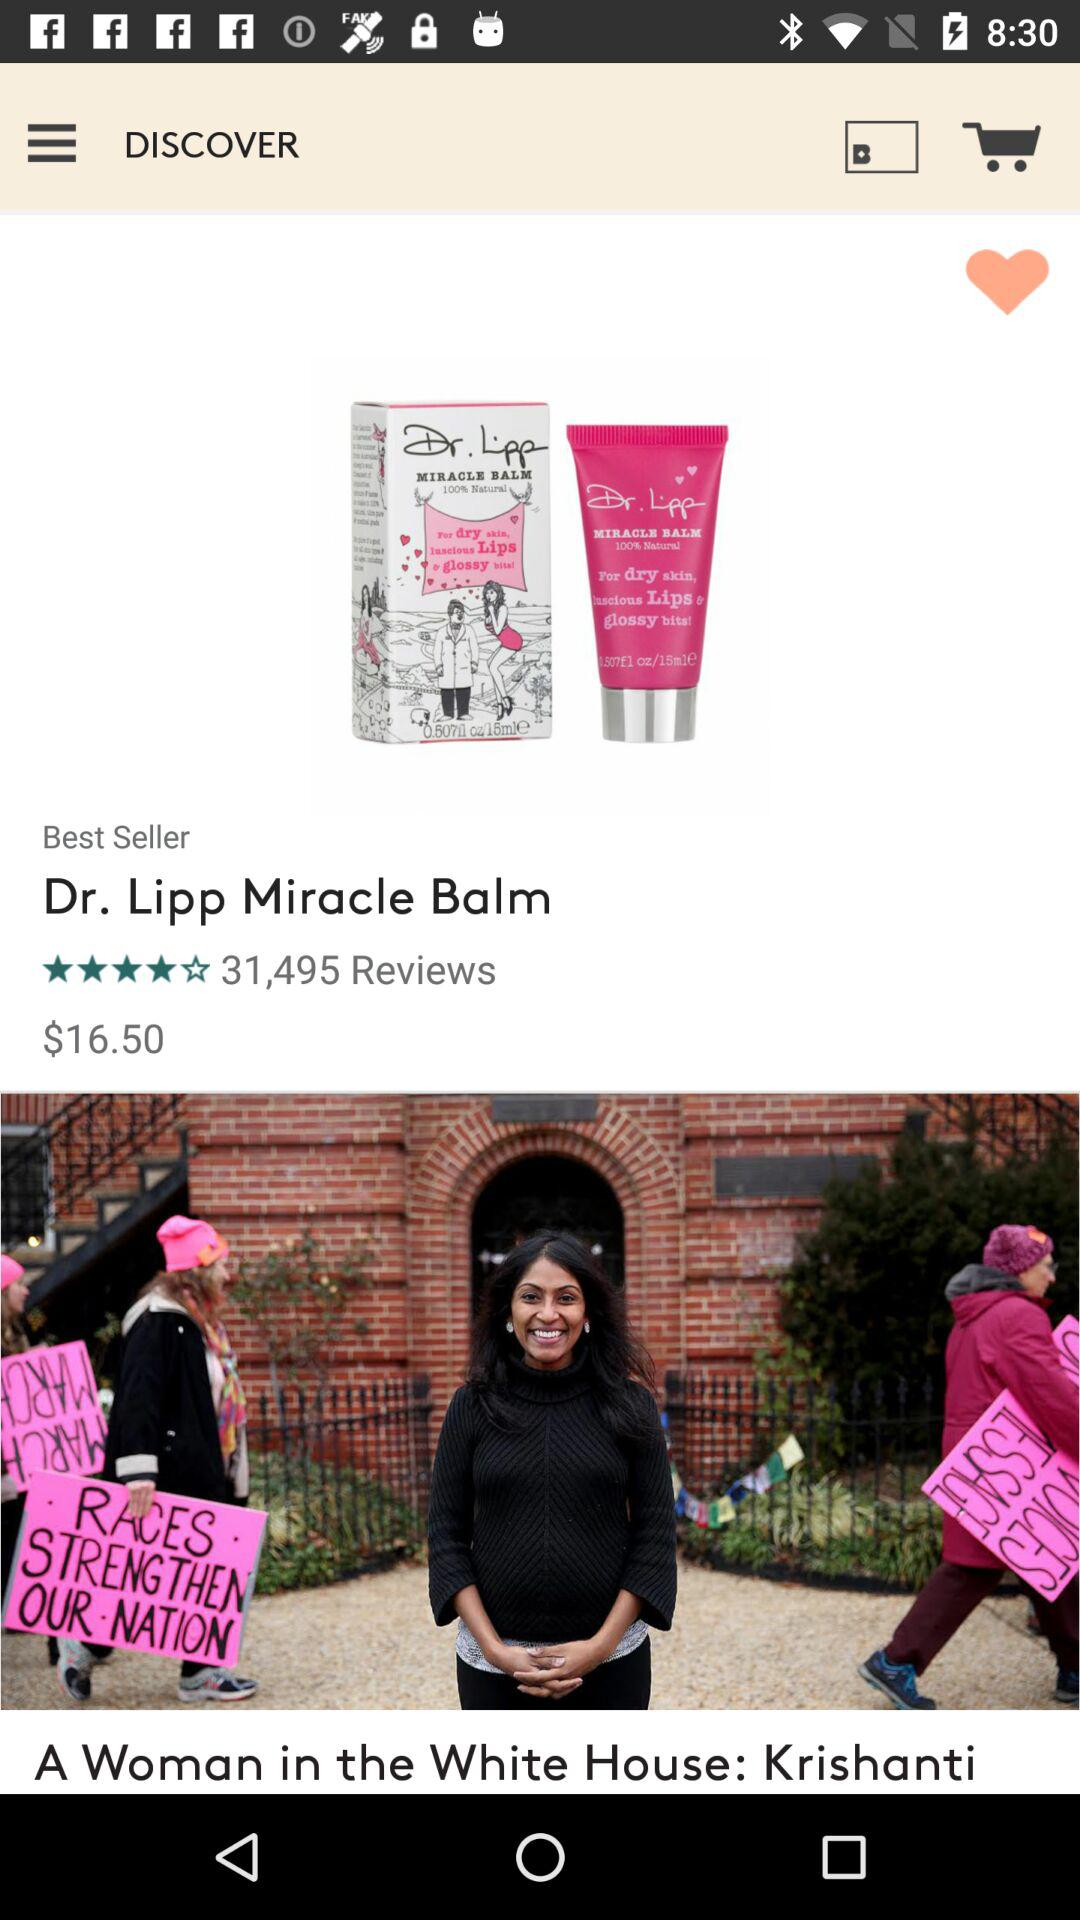What is the currency for the price? The currency is $. 